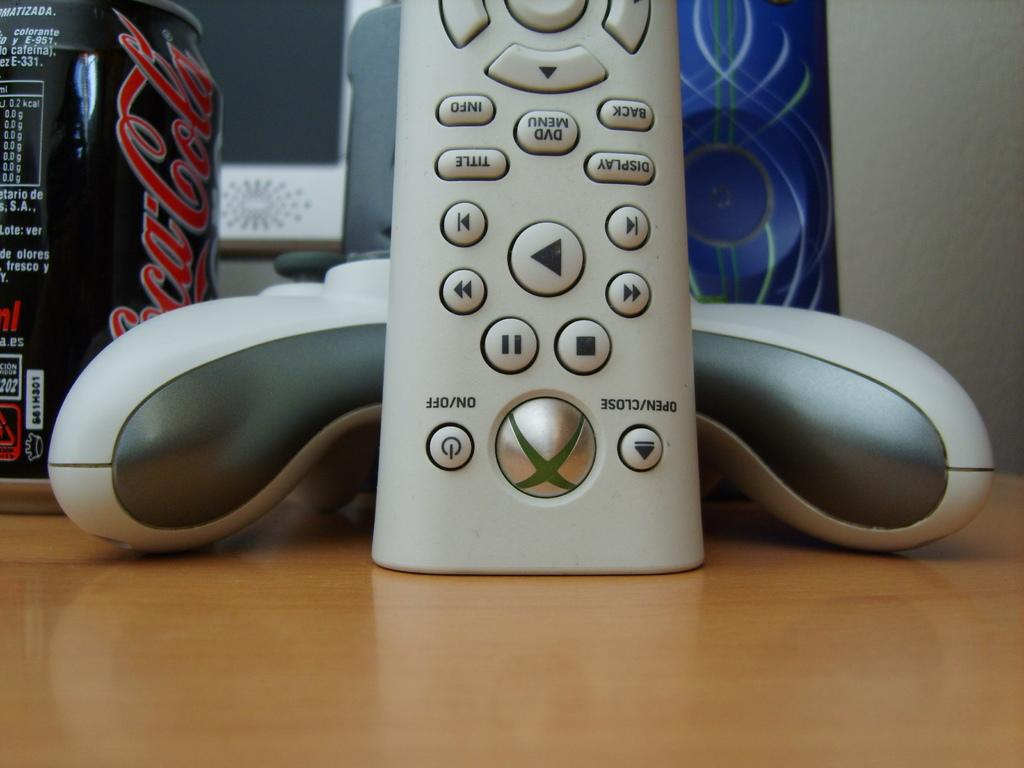What type of surface is visible in the image? There is a wooden surface in the image. What electronic device is on the wooden surface? A remote is present on the wooden surface. What beverage container is on the wooden surface? A coke can is on the wooden surface. What other objects can be seen on the wooden surface? There are other objects on the wooden surface. What is visible on the right side of the image? There is a wall on the right side of the image. What type of badge can be seen hanging on the wall in the image? There is no badge present in the image; only a wooden surface, a remote, a coke can, other objects, and a wall are visible. What type of prose is written on the wooden surface in the image? There is no prose written on the wooden surface in the image; it is a surface with objects on it. 